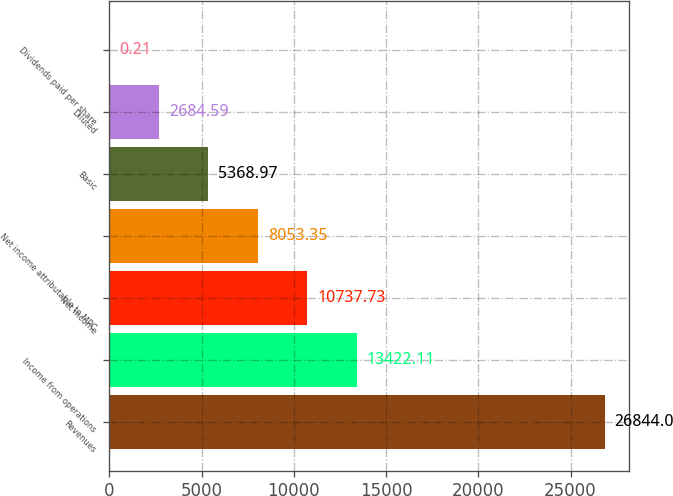<chart> <loc_0><loc_0><loc_500><loc_500><bar_chart><fcel>Revenues<fcel>Income from operations<fcel>Net income<fcel>Net income attributable to MPC<fcel>Basic<fcel>Diluted<fcel>Dividends paid per share<nl><fcel>26844<fcel>13422.1<fcel>10737.7<fcel>8053.35<fcel>5368.97<fcel>2684.59<fcel>0.21<nl></chart> 